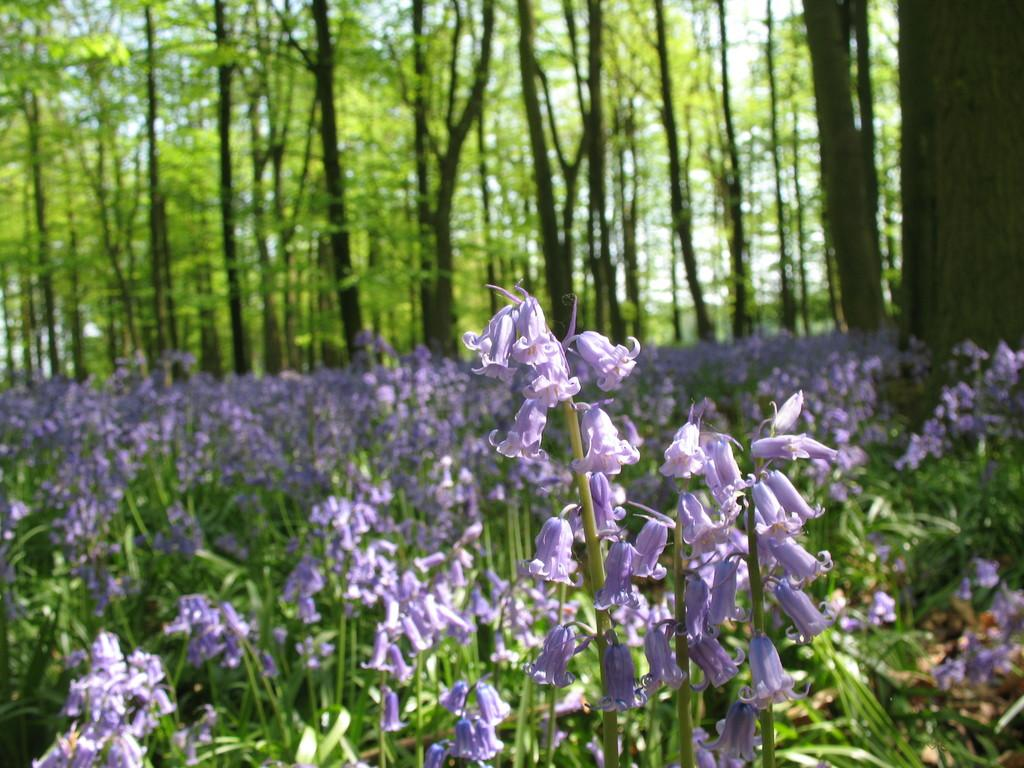What type of living organisms can be seen in the image? Plants and flowers are visible in the image. What color are the flowers in the image? The flowers are violet in color. What can be seen in the background of the image? Trees and the sky are visible in the background of the image. What is the condition of the sky in the image? The sky is clear and visible in the background of the image. Can you tell me how many hens are attacking the flowers in the image? There are no hens present in the image, and therefore no such attack can be observed. 